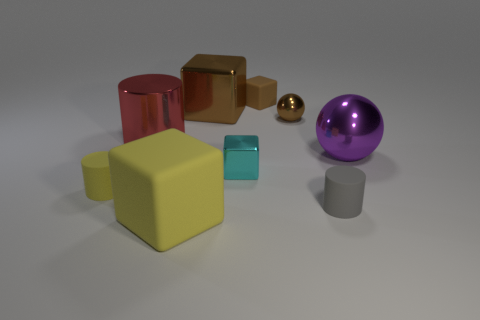Do the small cylinder on the left side of the small brown sphere and the large rubber object have the same color?
Your answer should be compact. Yes. What is the shape of the matte object behind the tiny rubber cylinder left of the rubber block that is in front of the tiny brown rubber object?
Provide a short and direct response. Cube. Does the red shiny cylinder have the same size as the cylinder on the right side of the yellow rubber cube?
Give a very brief answer. No. Are there any matte blocks of the same size as the gray cylinder?
Ensure brevity in your answer.  Yes. How many other objects are there of the same material as the tiny cyan thing?
Offer a very short reply. 4. What color is the small object that is both in front of the small brown cube and behind the large purple ball?
Offer a very short reply. Brown. Are the cube left of the large brown shiny block and the big block that is behind the tiny yellow object made of the same material?
Ensure brevity in your answer.  No. There is a yellow rubber object that is behind the gray matte thing; is its size the same as the brown matte object?
Offer a very short reply. Yes. There is a small shiny block; is it the same color as the big object in front of the small gray matte object?
Your answer should be compact. No. The tiny object that is the same color as the small rubber block is what shape?
Give a very brief answer. Sphere. 